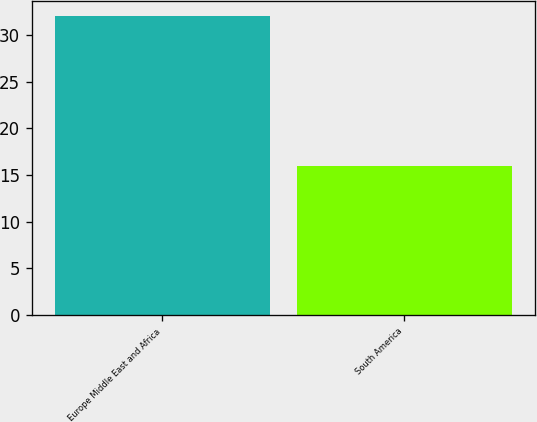Convert chart to OTSL. <chart><loc_0><loc_0><loc_500><loc_500><bar_chart><fcel>Europe Middle East and Africa<fcel>South America<nl><fcel>32<fcel>16<nl></chart> 